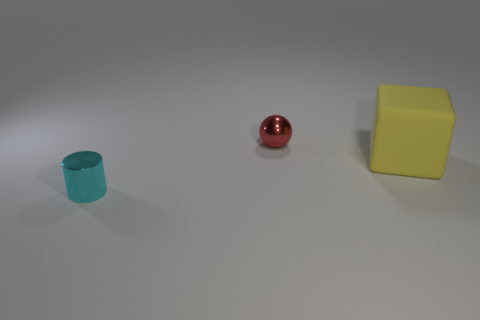There is a object behind the yellow object; what is its shape? The object behind the yellow cube is a sphere with a reflective red surface. 